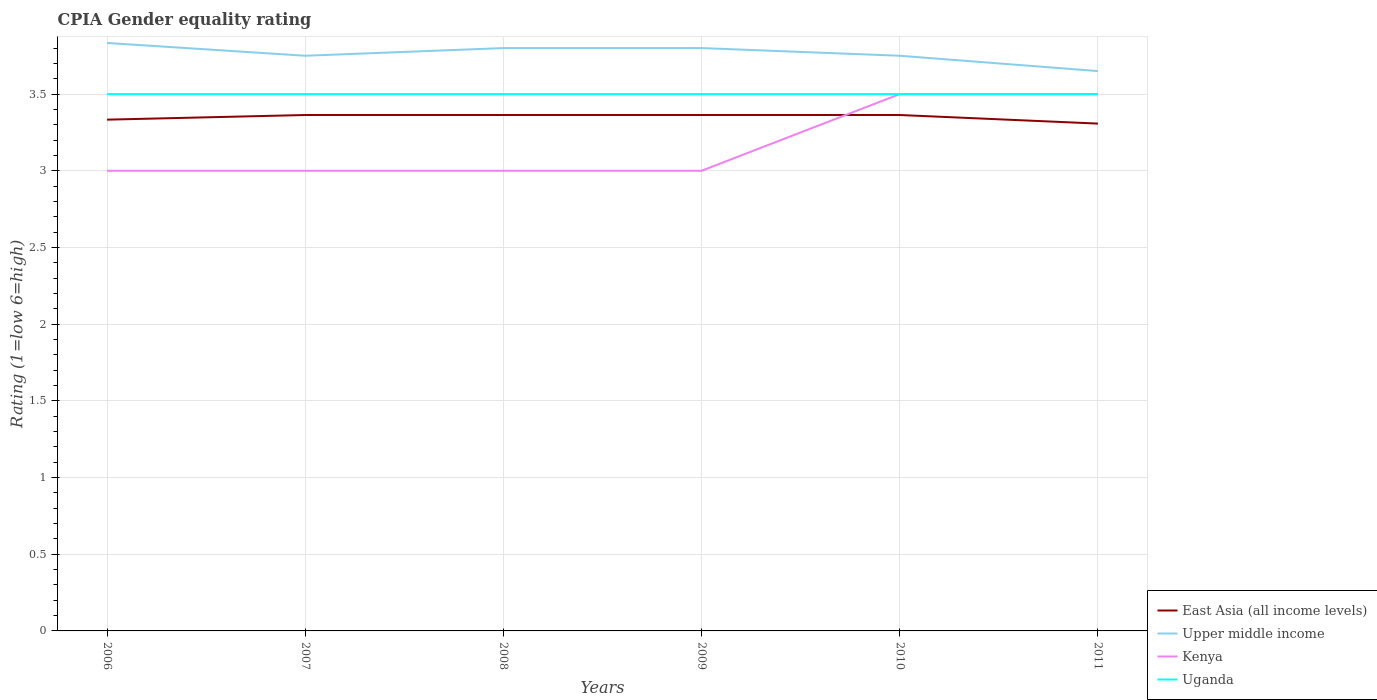Does the line corresponding to Kenya intersect with the line corresponding to East Asia (all income levels)?
Make the answer very short. Yes. What is the total CPIA rating in East Asia (all income levels) in the graph?
Offer a very short reply. -0.03. What is the difference between the highest and the second highest CPIA rating in Kenya?
Make the answer very short. 0.5. What is the difference between the highest and the lowest CPIA rating in Uganda?
Your response must be concise. 0. How many lines are there?
Ensure brevity in your answer.  4. Are the values on the major ticks of Y-axis written in scientific E-notation?
Offer a very short reply. No. Where does the legend appear in the graph?
Your response must be concise. Bottom right. How are the legend labels stacked?
Offer a very short reply. Vertical. What is the title of the graph?
Your answer should be compact. CPIA Gender equality rating. What is the Rating (1=low 6=high) of East Asia (all income levels) in 2006?
Give a very brief answer. 3.33. What is the Rating (1=low 6=high) of Upper middle income in 2006?
Give a very brief answer. 3.83. What is the Rating (1=low 6=high) in Kenya in 2006?
Provide a succinct answer. 3. What is the Rating (1=low 6=high) of East Asia (all income levels) in 2007?
Your answer should be compact. 3.36. What is the Rating (1=low 6=high) in Upper middle income in 2007?
Offer a very short reply. 3.75. What is the Rating (1=low 6=high) in East Asia (all income levels) in 2008?
Make the answer very short. 3.36. What is the Rating (1=low 6=high) of Kenya in 2008?
Make the answer very short. 3. What is the Rating (1=low 6=high) of East Asia (all income levels) in 2009?
Offer a very short reply. 3.36. What is the Rating (1=low 6=high) in Upper middle income in 2009?
Your answer should be compact. 3.8. What is the Rating (1=low 6=high) of Uganda in 2009?
Provide a succinct answer. 3.5. What is the Rating (1=low 6=high) of East Asia (all income levels) in 2010?
Ensure brevity in your answer.  3.36. What is the Rating (1=low 6=high) in Upper middle income in 2010?
Keep it short and to the point. 3.75. What is the Rating (1=low 6=high) of East Asia (all income levels) in 2011?
Give a very brief answer. 3.31. What is the Rating (1=low 6=high) in Upper middle income in 2011?
Make the answer very short. 3.65. What is the Rating (1=low 6=high) in Kenya in 2011?
Your answer should be very brief. 3.5. Across all years, what is the maximum Rating (1=low 6=high) in East Asia (all income levels)?
Offer a very short reply. 3.36. Across all years, what is the maximum Rating (1=low 6=high) of Upper middle income?
Give a very brief answer. 3.83. Across all years, what is the minimum Rating (1=low 6=high) in East Asia (all income levels)?
Provide a succinct answer. 3.31. Across all years, what is the minimum Rating (1=low 6=high) in Upper middle income?
Offer a terse response. 3.65. Across all years, what is the minimum Rating (1=low 6=high) in Kenya?
Provide a succinct answer. 3. Across all years, what is the minimum Rating (1=low 6=high) of Uganda?
Your answer should be compact. 3.5. What is the total Rating (1=low 6=high) of East Asia (all income levels) in the graph?
Offer a terse response. 20.1. What is the total Rating (1=low 6=high) of Upper middle income in the graph?
Your answer should be very brief. 22.58. What is the difference between the Rating (1=low 6=high) in East Asia (all income levels) in 2006 and that in 2007?
Provide a short and direct response. -0.03. What is the difference between the Rating (1=low 6=high) in Upper middle income in 2006 and that in 2007?
Ensure brevity in your answer.  0.08. What is the difference between the Rating (1=low 6=high) in Kenya in 2006 and that in 2007?
Your response must be concise. 0. What is the difference between the Rating (1=low 6=high) in Uganda in 2006 and that in 2007?
Ensure brevity in your answer.  0. What is the difference between the Rating (1=low 6=high) of East Asia (all income levels) in 2006 and that in 2008?
Offer a terse response. -0.03. What is the difference between the Rating (1=low 6=high) in Upper middle income in 2006 and that in 2008?
Your answer should be very brief. 0.03. What is the difference between the Rating (1=low 6=high) of Kenya in 2006 and that in 2008?
Your answer should be compact. 0. What is the difference between the Rating (1=low 6=high) of East Asia (all income levels) in 2006 and that in 2009?
Keep it short and to the point. -0.03. What is the difference between the Rating (1=low 6=high) of Upper middle income in 2006 and that in 2009?
Your answer should be very brief. 0.03. What is the difference between the Rating (1=low 6=high) in Uganda in 2006 and that in 2009?
Make the answer very short. 0. What is the difference between the Rating (1=low 6=high) of East Asia (all income levels) in 2006 and that in 2010?
Provide a succinct answer. -0.03. What is the difference between the Rating (1=low 6=high) of Upper middle income in 2006 and that in 2010?
Offer a very short reply. 0.08. What is the difference between the Rating (1=low 6=high) in Uganda in 2006 and that in 2010?
Provide a succinct answer. 0. What is the difference between the Rating (1=low 6=high) in East Asia (all income levels) in 2006 and that in 2011?
Offer a very short reply. 0.03. What is the difference between the Rating (1=low 6=high) of Upper middle income in 2006 and that in 2011?
Your answer should be compact. 0.18. What is the difference between the Rating (1=low 6=high) of East Asia (all income levels) in 2007 and that in 2008?
Give a very brief answer. 0. What is the difference between the Rating (1=low 6=high) of Upper middle income in 2007 and that in 2008?
Your response must be concise. -0.05. What is the difference between the Rating (1=low 6=high) of East Asia (all income levels) in 2007 and that in 2009?
Keep it short and to the point. 0. What is the difference between the Rating (1=low 6=high) of Upper middle income in 2007 and that in 2009?
Offer a very short reply. -0.05. What is the difference between the Rating (1=low 6=high) in Kenya in 2007 and that in 2009?
Your answer should be compact. 0. What is the difference between the Rating (1=low 6=high) in East Asia (all income levels) in 2007 and that in 2010?
Offer a very short reply. 0. What is the difference between the Rating (1=low 6=high) in Uganda in 2007 and that in 2010?
Make the answer very short. 0. What is the difference between the Rating (1=low 6=high) in East Asia (all income levels) in 2007 and that in 2011?
Give a very brief answer. 0.06. What is the difference between the Rating (1=low 6=high) of Kenya in 2007 and that in 2011?
Provide a succinct answer. -0.5. What is the difference between the Rating (1=low 6=high) of Upper middle income in 2008 and that in 2009?
Your response must be concise. 0. What is the difference between the Rating (1=low 6=high) of Kenya in 2008 and that in 2009?
Give a very brief answer. 0. What is the difference between the Rating (1=low 6=high) in Kenya in 2008 and that in 2010?
Keep it short and to the point. -0.5. What is the difference between the Rating (1=low 6=high) in Uganda in 2008 and that in 2010?
Provide a short and direct response. 0. What is the difference between the Rating (1=low 6=high) of East Asia (all income levels) in 2008 and that in 2011?
Your answer should be very brief. 0.06. What is the difference between the Rating (1=low 6=high) of Upper middle income in 2008 and that in 2011?
Your answer should be compact. 0.15. What is the difference between the Rating (1=low 6=high) of Uganda in 2008 and that in 2011?
Keep it short and to the point. 0. What is the difference between the Rating (1=low 6=high) in Kenya in 2009 and that in 2010?
Offer a very short reply. -0.5. What is the difference between the Rating (1=low 6=high) in East Asia (all income levels) in 2009 and that in 2011?
Provide a succinct answer. 0.06. What is the difference between the Rating (1=low 6=high) in East Asia (all income levels) in 2010 and that in 2011?
Offer a terse response. 0.06. What is the difference between the Rating (1=low 6=high) of Kenya in 2010 and that in 2011?
Your answer should be compact. 0. What is the difference between the Rating (1=low 6=high) of Uganda in 2010 and that in 2011?
Your response must be concise. 0. What is the difference between the Rating (1=low 6=high) of East Asia (all income levels) in 2006 and the Rating (1=low 6=high) of Upper middle income in 2007?
Ensure brevity in your answer.  -0.42. What is the difference between the Rating (1=low 6=high) of East Asia (all income levels) in 2006 and the Rating (1=low 6=high) of Kenya in 2007?
Offer a terse response. 0.33. What is the difference between the Rating (1=low 6=high) in East Asia (all income levels) in 2006 and the Rating (1=low 6=high) in Uganda in 2007?
Give a very brief answer. -0.17. What is the difference between the Rating (1=low 6=high) in Upper middle income in 2006 and the Rating (1=low 6=high) in Kenya in 2007?
Make the answer very short. 0.83. What is the difference between the Rating (1=low 6=high) in Kenya in 2006 and the Rating (1=low 6=high) in Uganda in 2007?
Give a very brief answer. -0.5. What is the difference between the Rating (1=low 6=high) in East Asia (all income levels) in 2006 and the Rating (1=low 6=high) in Upper middle income in 2008?
Your response must be concise. -0.47. What is the difference between the Rating (1=low 6=high) in East Asia (all income levels) in 2006 and the Rating (1=low 6=high) in Kenya in 2008?
Give a very brief answer. 0.33. What is the difference between the Rating (1=low 6=high) of East Asia (all income levels) in 2006 and the Rating (1=low 6=high) of Uganda in 2008?
Keep it short and to the point. -0.17. What is the difference between the Rating (1=low 6=high) of Upper middle income in 2006 and the Rating (1=low 6=high) of Kenya in 2008?
Provide a short and direct response. 0.83. What is the difference between the Rating (1=low 6=high) of Upper middle income in 2006 and the Rating (1=low 6=high) of Uganda in 2008?
Offer a very short reply. 0.33. What is the difference between the Rating (1=low 6=high) of East Asia (all income levels) in 2006 and the Rating (1=low 6=high) of Upper middle income in 2009?
Give a very brief answer. -0.47. What is the difference between the Rating (1=low 6=high) in Upper middle income in 2006 and the Rating (1=low 6=high) in Kenya in 2009?
Offer a very short reply. 0.83. What is the difference between the Rating (1=low 6=high) in Kenya in 2006 and the Rating (1=low 6=high) in Uganda in 2009?
Keep it short and to the point. -0.5. What is the difference between the Rating (1=low 6=high) in East Asia (all income levels) in 2006 and the Rating (1=low 6=high) in Upper middle income in 2010?
Offer a very short reply. -0.42. What is the difference between the Rating (1=low 6=high) of East Asia (all income levels) in 2006 and the Rating (1=low 6=high) of Upper middle income in 2011?
Ensure brevity in your answer.  -0.32. What is the difference between the Rating (1=low 6=high) in Kenya in 2006 and the Rating (1=low 6=high) in Uganda in 2011?
Keep it short and to the point. -0.5. What is the difference between the Rating (1=low 6=high) in East Asia (all income levels) in 2007 and the Rating (1=low 6=high) in Upper middle income in 2008?
Offer a terse response. -0.44. What is the difference between the Rating (1=low 6=high) of East Asia (all income levels) in 2007 and the Rating (1=low 6=high) of Kenya in 2008?
Give a very brief answer. 0.36. What is the difference between the Rating (1=low 6=high) in East Asia (all income levels) in 2007 and the Rating (1=low 6=high) in Uganda in 2008?
Ensure brevity in your answer.  -0.14. What is the difference between the Rating (1=low 6=high) in Upper middle income in 2007 and the Rating (1=low 6=high) in Uganda in 2008?
Provide a succinct answer. 0.25. What is the difference between the Rating (1=low 6=high) of East Asia (all income levels) in 2007 and the Rating (1=low 6=high) of Upper middle income in 2009?
Make the answer very short. -0.44. What is the difference between the Rating (1=low 6=high) of East Asia (all income levels) in 2007 and the Rating (1=low 6=high) of Kenya in 2009?
Provide a short and direct response. 0.36. What is the difference between the Rating (1=low 6=high) in East Asia (all income levels) in 2007 and the Rating (1=low 6=high) in Uganda in 2009?
Keep it short and to the point. -0.14. What is the difference between the Rating (1=low 6=high) in Upper middle income in 2007 and the Rating (1=low 6=high) in Uganda in 2009?
Provide a succinct answer. 0.25. What is the difference between the Rating (1=low 6=high) of East Asia (all income levels) in 2007 and the Rating (1=low 6=high) of Upper middle income in 2010?
Offer a very short reply. -0.39. What is the difference between the Rating (1=low 6=high) in East Asia (all income levels) in 2007 and the Rating (1=low 6=high) in Kenya in 2010?
Give a very brief answer. -0.14. What is the difference between the Rating (1=low 6=high) of East Asia (all income levels) in 2007 and the Rating (1=low 6=high) of Uganda in 2010?
Provide a succinct answer. -0.14. What is the difference between the Rating (1=low 6=high) of Kenya in 2007 and the Rating (1=low 6=high) of Uganda in 2010?
Make the answer very short. -0.5. What is the difference between the Rating (1=low 6=high) in East Asia (all income levels) in 2007 and the Rating (1=low 6=high) in Upper middle income in 2011?
Your answer should be compact. -0.29. What is the difference between the Rating (1=low 6=high) of East Asia (all income levels) in 2007 and the Rating (1=low 6=high) of Kenya in 2011?
Your response must be concise. -0.14. What is the difference between the Rating (1=low 6=high) in East Asia (all income levels) in 2007 and the Rating (1=low 6=high) in Uganda in 2011?
Your answer should be compact. -0.14. What is the difference between the Rating (1=low 6=high) in Upper middle income in 2007 and the Rating (1=low 6=high) in Kenya in 2011?
Your answer should be compact. 0.25. What is the difference between the Rating (1=low 6=high) of Upper middle income in 2007 and the Rating (1=low 6=high) of Uganda in 2011?
Keep it short and to the point. 0.25. What is the difference between the Rating (1=low 6=high) of East Asia (all income levels) in 2008 and the Rating (1=low 6=high) of Upper middle income in 2009?
Provide a short and direct response. -0.44. What is the difference between the Rating (1=low 6=high) in East Asia (all income levels) in 2008 and the Rating (1=low 6=high) in Kenya in 2009?
Keep it short and to the point. 0.36. What is the difference between the Rating (1=low 6=high) in East Asia (all income levels) in 2008 and the Rating (1=low 6=high) in Uganda in 2009?
Offer a very short reply. -0.14. What is the difference between the Rating (1=low 6=high) in Upper middle income in 2008 and the Rating (1=low 6=high) in Uganda in 2009?
Give a very brief answer. 0.3. What is the difference between the Rating (1=low 6=high) in East Asia (all income levels) in 2008 and the Rating (1=low 6=high) in Upper middle income in 2010?
Offer a very short reply. -0.39. What is the difference between the Rating (1=low 6=high) in East Asia (all income levels) in 2008 and the Rating (1=low 6=high) in Kenya in 2010?
Offer a terse response. -0.14. What is the difference between the Rating (1=low 6=high) of East Asia (all income levels) in 2008 and the Rating (1=low 6=high) of Uganda in 2010?
Give a very brief answer. -0.14. What is the difference between the Rating (1=low 6=high) of East Asia (all income levels) in 2008 and the Rating (1=low 6=high) of Upper middle income in 2011?
Provide a succinct answer. -0.29. What is the difference between the Rating (1=low 6=high) in East Asia (all income levels) in 2008 and the Rating (1=low 6=high) in Kenya in 2011?
Offer a very short reply. -0.14. What is the difference between the Rating (1=low 6=high) of East Asia (all income levels) in 2008 and the Rating (1=low 6=high) of Uganda in 2011?
Provide a succinct answer. -0.14. What is the difference between the Rating (1=low 6=high) in East Asia (all income levels) in 2009 and the Rating (1=low 6=high) in Upper middle income in 2010?
Give a very brief answer. -0.39. What is the difference between the Rating (1=low 6=high) of East Asia (all income levels) in 2009 and the Rating (1=low 6=high) of Kenya in 2010?
Your response must be concise. -0.14. What is the difference between the Rating (1=low 6=high) in East Asia (all income levels) in 2009 and the Rating (1=low 6=high) in Uganda in 2010?
Keep it short and to the point. -0.14. What is the difference between the Rating (1=low 6=high) in East Asia (all income levels) in 2009 and the Rating (1=low 6=high) in Upper middle income in 2011?
Offer a very short reply. -0.29. What is the difference between the Rating (1=low 6=high) in East Asia (all income levels) in 2009 and the Rating (1=low 6=high) in Kenya in 2011?
Offer a very short reply. -0.14. What is the difference between the Rating (1=low 6=high) in East Asia (all income levels) in 2009 and the Rating (1=low 6=high) in Uganda in 2011?
Ensure brevity in your answer.  -0.14. What is the difference between the Rating (1=low 6=high) in Upper middle income in 2009 and the Rating (1=low 6=high) in Kenya in 2011?
Give a very brief answer. 0.3. What is the difference between the Rating (1=low 6=high) in Upper middle income in 2009 and the Rating (1=low 6=high) in Uganda in 2011?
Provide a succinct answer. 0.3. What is the difference between the Rating (1=low 6=high) in Kenya in 2009 and the Rating (1=low 6=high) in Uganda in 2011?
Make the answer very short. -0.5. What is the difference between the Rating (1=low 6=high) of East Asia (all income levels) in 2010 and the Rating (1=low 6=high) of Upper middle income in 2011?
Provide a succinct answer. -0.29. What is the difference between the Rating (1=low 6=high) of East Asia (all income levels) in 2010 and the Rating (1=low 6=high) of Kenya in 2011?
Provide a short and direct response. -0.14. What is the difference between the Rating (1=low 6=high) of East Asia (all income levels) in 2010 and the Rating (1=low 6=high) of Uganda in 2011?
Keep it short and to the point. -0.14. What is the average Rating (1=low 6=high) in East Asia (all income levels) per year?
Make the answer very short. 3.35. What is the average Rating (1=low 6=high) in Upper middle income per year?
Keep it short and to the point. 3.76. What is the average Rating (1=low 6=high) of Kenya per year?
Your answer should be very brief. 3.17. In the year 2006, what is the difference between the Rating (1=low 6=high) of East Asia (all income levels) and Rating (1=low 6=high) of Upper middle income?
Provide a succinct answer. -0.5. In the year 2006, what is the difference between the Rating (1=low 6=high) of East Asia (all income levels) and Rating (1=low 6=high) of Kenya?
Your response must be concise. 0.33. In the year 2006, what is the difference between the Rating (1=low 6=high) in East Asia (all income levels) and Rating (1=low 6=high) in Uganda?
Ensure brevity in your answer.  -0.17. In the year 2006, what is the difference between the Rating (1=low 6=high) in Upper middle income and Rating (1=low 6=high) in Kenya?
Offer a terse response. 0.83. In the year 2006, what is the difference between the Rating (1=low 6=high) of Upper middle income and Rating (1=low 6=high) of Uganda?
Your answer should be very brief. 0.33. In the year 2006, what is the difference between the Rating (1=low 6=high) in Kenya and Rating (1=low 6=high) in Uganda?
Provide a succinct answer. -0.5. In the year 2007, what is the difference between the Rating (1=low 6=high) in East Asia (all income levels) and Rating (1=low 6=high) in Upper middle income?
Give a very brief answer. -0.39. In the year 2007, what is the difference between the Rating (1=low 6=high) of East Asia (all income levels) and Rating (1=low 6=high) of Kenya?
Provide a succinct answer. 0.36. In the year 2007, what is the difference between the Rating (1=low 6=high) of East Asia (all income levels) and Rating (1=low 6=high) of Uganda?
Keep it short and to the point. -0.14. In the year 2007, what is the difference between the Rating (1=low 6=high) of Upper middle income and Rating (1=low 6=high) of Kenya?
Keep it short and to the point. 0.75. In the year 2007, what is the difference between the Rating (1=low 6=high) of Upper middle income and Rating (1=low 6=high) of Uganda?
Your answer should be very brief. 0.25. In the year 2008, what is the difference between the Rating (1=low 6=high) of East Asia (all income levels) and Rating (1=low 6=high) of Upper middle income?
Offer a terse response. -0.44. In the year 2008, what is the difference between the Rating (1=low 6=high) in East Asia (all income levels) and Rating (1=low 6=high) in Kenya?
Provide a short and direct response. 0.36. In the year 2008, what is the difference between the Rating (1=low 6=high) of East Asia (all income levels) and Rating (1=low 6=high) of Uganda?
Your answer should be very brief. -0.14. In the year 2008, what is the difference between the Rating (1=low 6=high) of Upper middle income and Rating (1=low 6=high) of Kenya?
Make the answer very short. 0.8. In the year 2009, what is the difference between the Rating (1=low 6=high) of East Asia (all income levels) and Rating (1=low 6=high) of Upper middle income?
Give a very brief answer. -0.44. In the year 2009, what is the difference between the Rating (1=low 6=high) in East Asia (all income levels) and Rating (1=low 6=high) in Kenya?
Your answer should be compact. 0.36. In the year 2009, what is the difference between the Rating (1=low 6=high) in East Asia (all income levels) and Rating (1=low 6=high) in Uganda?
Your response must be concise. -0.14. In the year 2009, what is the difference between the Rating (1=low 6=high) of Upper middle income and Rating (1=low 6=high) of Kenya?
Provide a short and direct response. 0.8. In the year 2009, what is the difference between the Rating (1=low 6=high) of Upper middle income and Rating (1=low 6=high) of Uganda?
Provide a succinct answer. 0.3. In the year 2009, what is the difference between the Rating (1=low 6=high) of Kenya and Rating (1=low 6=high) of Uganda?
Your response must be concise. -0.5. In the year 2010, what is the difference between the Rating (1=low 6=high) of East Asia (all income levels) and Rating (1=low 6=high) of Upper middle income?
Make the answer very short. -0.39. In the year 2010, what is the difference between the Rating (1=low 6=high) of East Asia (all income levels) and Rating (1=low 6=high) of Kenya?
Give a very brief answer. -0.14. In the year 2010, what is the difference between the Rating (1=low 6=high) in East Asia (all income levels) and Rating (1=low 6=high) in Uganda?
Make the answer very short. -0.14. In the year 2010, what is the difference between the Rating (1=low 6=high) in Kenya and Rating (1=low 6=high) in Uganda?
Give a very brief answer. 0. In the year 2011, what is the difference between the Rating (1=low 6=high) of East Asia (all income levels) and Rating (1=low 6=high) of Upper middle income?
Provide a short and direct response. -0.34. In the year 2011, what is the difference between the Rating (1=low 6=high) of East Asia (all income levels) and Rating (1=low 6=high) of Kenya?
Keep it short and to the point. -0.19. In the year 2011, what is the difference between the Rating (1=low 6=high) of East Asia (all income levels) and Rating (1=low 6=high) of Uganda?
Offer a very short reply. -0.19. In the year 2011, what is the difference between the Rating (1=low 6=high) in Upper middle income and Rating (1=low 6=high) in Kenya?
Provide a short and direct response. 0.15. In the year 2011, what is the difference between the Rating (1=low 6=high) of Upper middle income and Rating (1=low 6=high) of Uganda?
Keep it short and to the point. 0.15. What is the ratio of the Rating (1=low 6=high) of Upper middle income in 2006 to that in 2007?
Your answer should be compact. 1.02. What is the ratio of the Rating (1=low 6=high) in Kenya in 2006 to that in 2007?
Provide a succinct answer. 1. What is the ratio of the Rating (1=low 6=high) of Uganda in 2006 to that in 2007?
Ensure brevity in your answer.  1. What is the ratio of the Rating (1=low 6=high) of Upper middle income in 2006 to that in 2008?
Provide a short and direct response. 1.01. What is the ratio of the Rating (1=low 6=high) in Kenya in 2006 to that in 2008?
Ensure brevity in your answer.  1. What is the ratio of the Rating (1=low 6=high) of Uganda in 2006 to that in 2008?
Provide a short and direct response. 1. What is the ratio of the Rating (1=low 6=high) in Upper middle income in 2006 to that in 2009?
Make the answer very short. 1.01. What is the ratio of the Rating (1=low 6=high) of Kenya in 2006 to that in 2009?
Offer a very short reply. 1. What is the ratio of the Rating (1=low 6=high) of East Asia (all income levels) in 2006 to that in 2010?
Provide a short and direct response. 0.99. What is the ratio of the Rating (1=low 6=high) of Upper middle income in 2006 to that in 2010?
Make the answer very short. 1.02. What is the ratio of the Rating (1=low 6=high) in Kenya in 2006 to that in 2010?
Offer a terse response. 0.86. What is the ratio of the Rating (1=low 6=high) of Uganda in 2006 to that in 2010?
Make the answer very short. 1. What is the ratio of the Rating (1=low 6=high) of East Asia (all income levels) in 2006 to that in 2011?
Keep it short and to the point. 1.01. What is the ratio of the Rating (1=low 6=high) in Upper middle income in 2006 to that in 2011?
Make the answer very short. 1.05. What is the ratio of the Rating (1=low 6=high) in Upper middle income in 2007 to that in 2008?
Offer a terse response. 0.99. What is the ratio of the Rating (1=low 6=high) in Kenya in 2007 to that in 2008?
Make the answer very short. 1. What is the ratio of the Rating (1=low 6=high) of Uganda in 2007 to that in 2008?
Your answer should be compact. 1. What is the ratio of the Rating (1=low 6=high) of East Asia (all income levels) in 2007 to that in 2009?
Keep it short and to the point. 1. What is the ratio of the Rating (1=low 6=high) of Upper middle income in 2007 to that in 2009?
Give a very brief answer. 0.99. What is the ratio of the Rating (1=low 6=high) in Upper middle income in 2007 to that in 2010?
Keep it short and to the point. 1. What is the ratio of the Rating (1=low 6=high) in Kenya in 2007 to that in 2010?
Ensure brevity in your answer.  0.86. What is the ratio of the Rating (1=low 6=high) in East Asia (all income levels) in 2007 to that in 2011?
Keep it short and to the point. 1.02. What is the ratio of the Rating (1=low 6=high) of Upper middle income in 2007 to that in 2011?
Your answer should be compact. 1.03. What is the ratio of the Rating (1=low 6=high) in Uganda in 2007 to that in 2011?
Give a very brief answer. 1. What is the ratio of the Rating (1=low 6=high) of Uganda in 2008 to that in 2009?
Ensure brevity in your answer.  1. What is the ratio of the Rating (1=low 6=high) in Upper middle income in 2008 to that in 2010?
Offer a very short reply. 1.01. What is the ratio of the Rating (1=low 6=high) of East Asia (all income levels) in 2008 to that in 2011?
Provide a succinct answer. 1.02. What is the ratio of the Rating (1=low 6=high) in Upper middle income in 2008 to that in 2011?
Give a very brief answer. 1.04. What is the ratio of the Rating (1=low 6=high) of Kenya in 2008 to that in 2011?
Offer a terse response. 0.86. What is the ratio of the Rating (1=low 6=high) in East Asia (all income levels) in 2009 to that in 2010?
Provide a succinct answer. 1. What is the ratio of the Rating (1=low 6=high) in Upper middle income in 2009 to that in 2010?
Your answer should be very brief. 1.01. What is the ratio of the Rating (1=low 6=high) in Kenya in 2009 to that in 2010?
Make the answer very short. 0.86. What is the ratio of the Rating (1=low 6=high) in Uganda in 2009 to that in 2010?
Provide a succinct answer. 1. What is the ratio of the Rating (1=low 6=high) of East Asia (all income levels) in 2009 to that in 2011?
Ensure brevity in your answer.  1.02. What is the ratio of the Rating (1=low 6=high) in Upper middle income in 2009 to that in 2011?
Provide a succinct answer. 1.04. What is the ratio of the Rating (1=low 6=high) of Uganda in 2009 to that in 2011?
Make the answer very short. 1. What is the ratio of the Rating (1=low 6=high) of East Asia (all income levels) in 2010 to that in 2011?
Offer a very short reply. 1.02. What is the ratio of the Rating (1=low 6=high) of Upper middle income in 2010 to that in 2011?
Give a very brief answer. 1.03. What is the ratio of the Rating (1=low 6=high) of Kenya in 2010 to that in 2011?
Your answer should be very brief. 1. What is the ratio of the Rating (1=low 6=high) of Uganda in 2010 to that in 2011?
Ensure brevity in your answer.  1. What is the difference between the highest and the second highest Rating (1=low 6=high) in East Asia (all income levels)?
Make the answer very short. 0. What is the difference between the highest and the lowest Rating (1=low 6=high) of East Asia (all income levels)?
Offer a terse response. 0.06. What is the difference between the highest and the lowest Rating (1=low 6=high) of Upper middle income?
Your response must be concise. 0.18. What is the difference between the highest and the lowest Rating (1=low 6=high) in Kenya?
Keep it short and to the point. 0.5. 